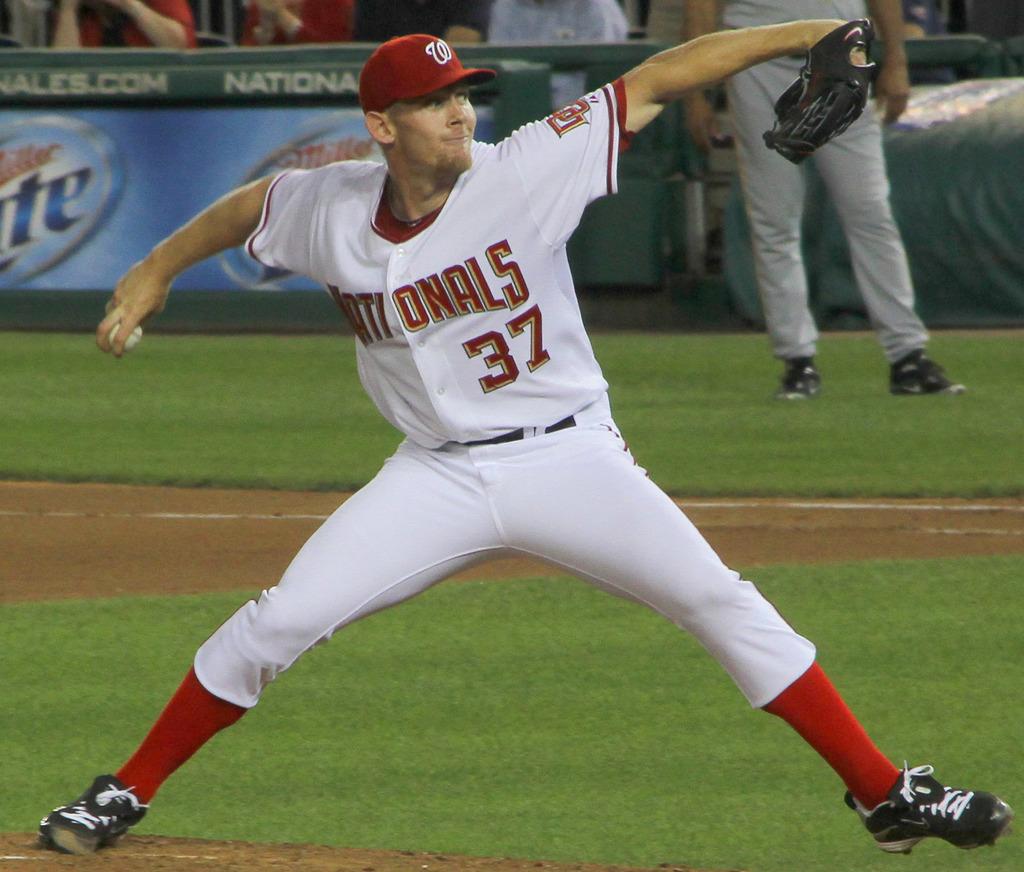What is the number of this player?
Provide a succinct answer. 37. 